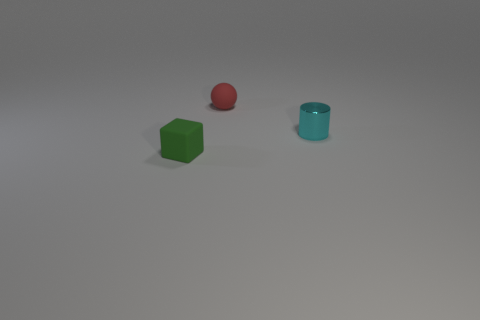Add 2 large blue metal cylinders. How many objects exist? 5 Subtract 0 brown cubes. How many objects are left? 3 Subtract all spheres. How many objects are left? 2 Subtract 1 blocks. How many blocks are left? 0 Subtract all brown cylinders. Subtract all yellow balls. How many cylinders are left? 1 Subtract all blue cubes. How many gray cylinders are left? 0 Subtract all large green rubber things. Subtract all matte cubes. How many objects are left? 2 Add 1 tiny green rubber blocks. How many tiny green rubber blocks are left? 2 Add 3 gray things. How many gray things exist? 3 